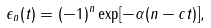<formula> <loc_0><loc_0><loc_500><loc_500>\epsilon _ { n } ( t ) = ( - 1 ) ^ { n } \exp [ - \alpha ( n - c t ) ] ,</formula> 